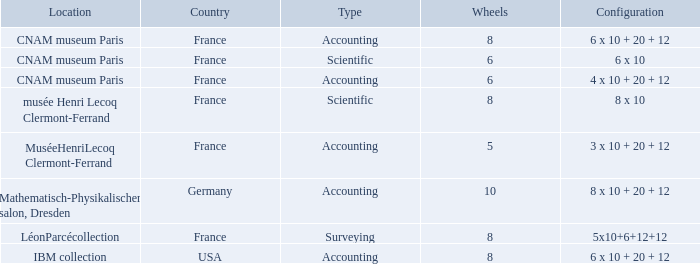What is the setup for france as the country, with accounting as the category, and more than 6 wheels? 6 x 10 + 20 + 12. 